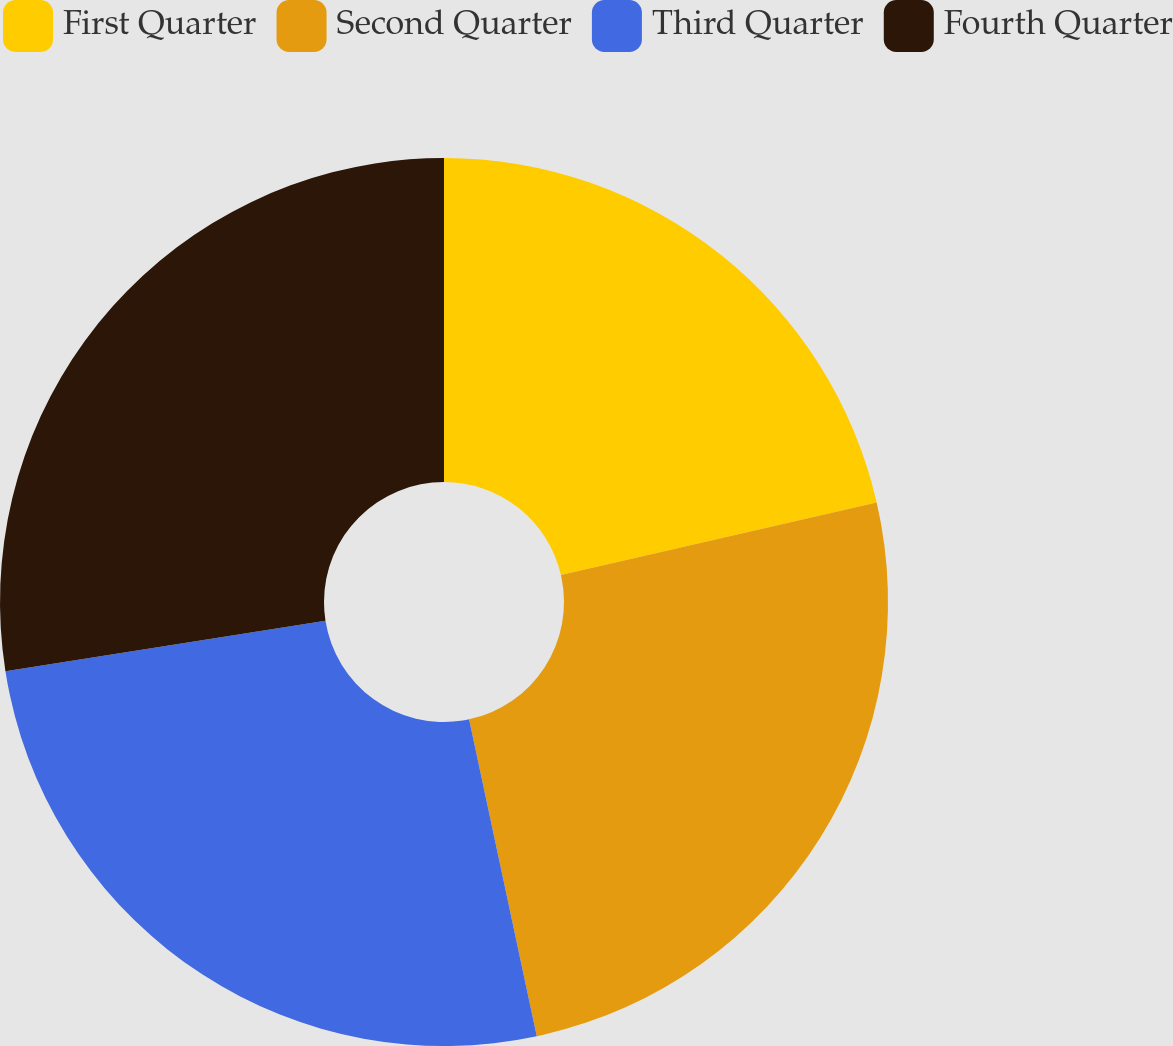Convert chart. <chart><loc_0><loc_0><loc_500><loc_500><pie_chart><fcel>First Quarter<fcel>Second Quarter<fcel>Third Quarter<fcel>Fourth Quarter<nl><fcel>21.4%<fcel>25.25%<fcel>25.86%<fcel>27.49%<nl></chart> 